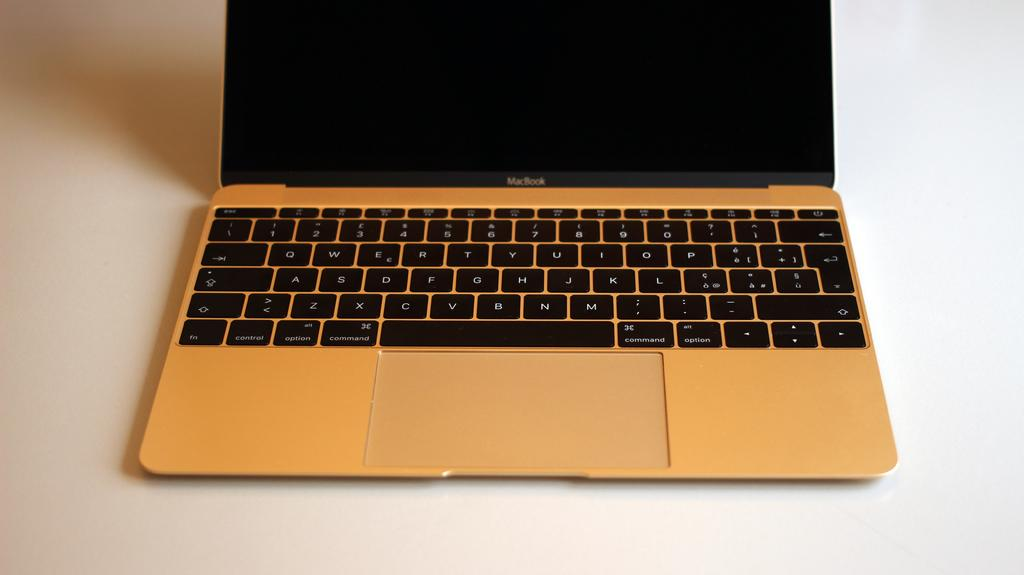<image>
Create a compact narrative representing the image presented. MacBook is written on this open laptop with a full keyboard ready for use. 